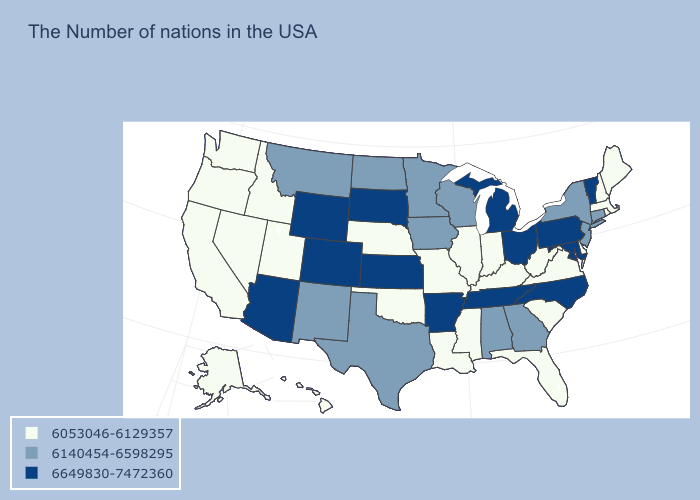Name the states that have a value in the range 6140454-6598295?
Concise answer only. Connecticut, New York, New Jersey, Georgia, Alabama, Wisconsin, Minnesota, Iowa, Texas, North Dakota, New Mexico, Montana. Which states have the highest value in the USA?
Short answer required. Vermont, Maryland, Pennsylvania, North Carolina, Ohio, Michigan, Tennessee, Arkansas, Kansas, South Dakota, Wyoming, Colorado, Arizona. Which states have the lowest value in the USA?
Keep it brief. Maine, Massachusetts, Rhode Island, New Hampshire, Delaware, Virginia, South Carolina, West Virginia, Florida, Kentucky, Indiana, Illinois, Mississippi, Louisiana, Missouri, Nebraska, Oklahoma, Utah, Idaho, Nevada, California, Washington, Oregon, Alaska, Hawaii. Which states have the lowest value in the South?
Quick response, please. Delaware, Virginia, South Carolina, West Virginia, Florida, Kentucky, Mississippi, Louisiana, Oklahoma. What is the value of Connecticut?
Give a very brief answer. 6140454-6598295. What is the highest value in the West ?
Write a very short answer. 6649830-7472360. Among the states that border New York , does Connecticut have the highest value?
Quick response, please. No. Which states hav the highest value in the South?
Give a very brief answer. Maryland, North Carolina, Tennessee, Arkansas. What is the highest value in the West ?
Quick response, please. 6649830-7472360. Which states have the lowest value in the USA?
Quick response, please. Maine, Massachusetts, Rhode Island, New Hampshire, Delaware, Virginia, South Carolina, West Virginia, Florida, Kentucky, Indiana, Illinois, Mississippi, Louisiana, Missouri, Nebraska, Oklahoma, Utah, Idaho, Nevada, California, Washington, Oregon, Alaska, Hawaii. What is the lowest value in the South?
Give a very brief answer. 6053046-6129357. What is the highest value in the USA?
Keep it brief. 6649830-7472360. Name the states that have a value in the range 6053046-6129357?
Short answer required. Maine, Massachusetts, Rhode Island, New Hampshire, Delaware, Virginia, South Carolina, West Virginia, Florida, Kentucky, Indiana, Illinois, Mississippi, Louisiana, Missouri, Nebraska, Oklahoma, Utah, Idaho, Nevada, California, Washington, Oregon, Alaska, Hawaii. Does North Carolina have a higher value than Wyoming?
Write a very short answer. No. What is the value of Connecticut?
Be succinct. 6140454-6598295. 